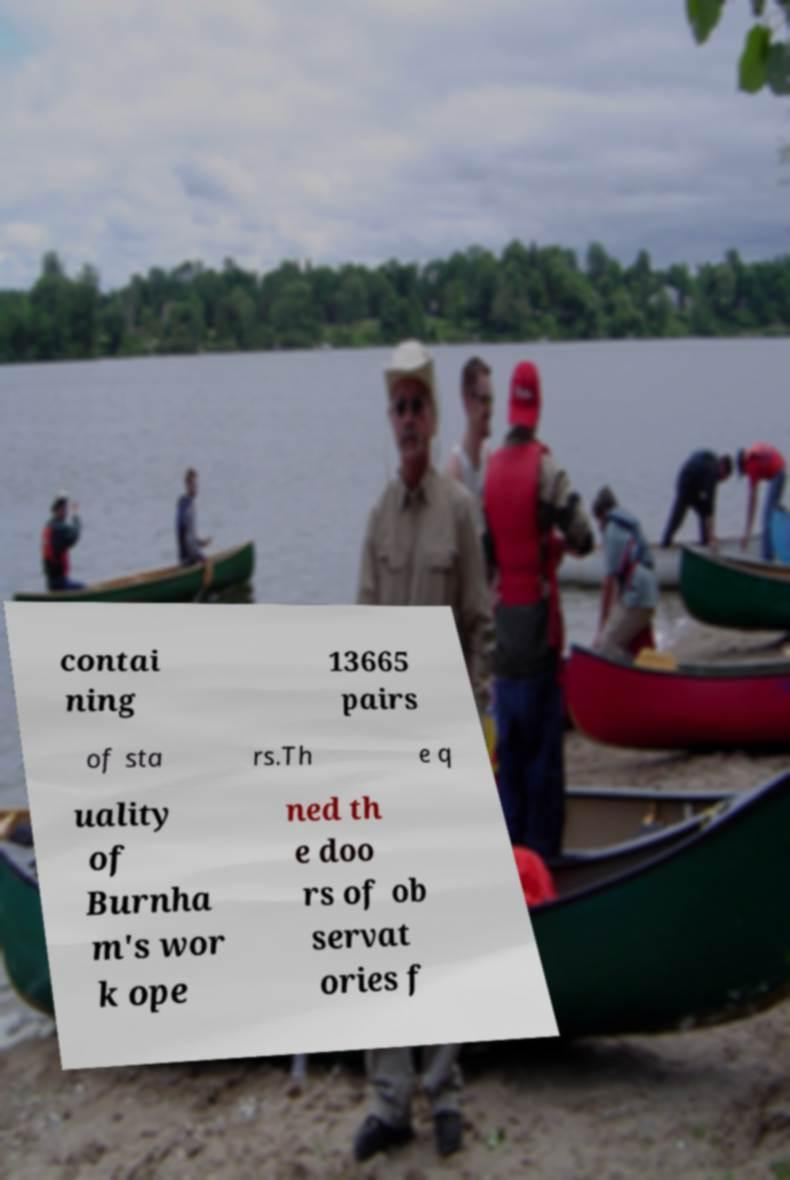For documentation purposes, I need the text within this image transcribed. Could you provide that? contai ning 13665 pairs of sta rs.Th e q uality of Burnha m's wor k ope ned th e doo rs of ob servat ories f 